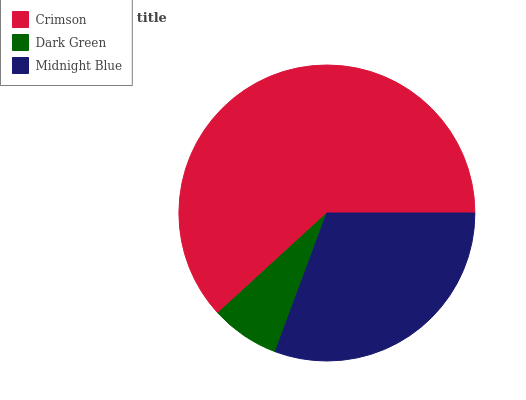Is Dark Green the minimum?
Answer yes or no. Yes. Is Crimson the maximum?
Answer yes or no. Yes. Is Midnight Blue the minimum?
Answer yes or no. No. Is Midnight Blue the maximum?
Answer yes or no. No. Is Midnight Blue greater than Dark Green?
Answer yes or no. Yes. Is Dark Green less than Midnight Blue?
Answer yes or no. Yes. Is Dark Green greater than Midnight Blue?
Answer yes or no. No. Is Midnight Blue less than Dark Green?
Answer yes or no. No. Is Midnight Blue the high median?
Answer yes or no. Yes. Is Midnight Blue the low median?
Answer yes or no. Yes. Is Crimson the high median?
Answer yes or no. No. Is Dark Green the low median?
Answer yes or no. No. 